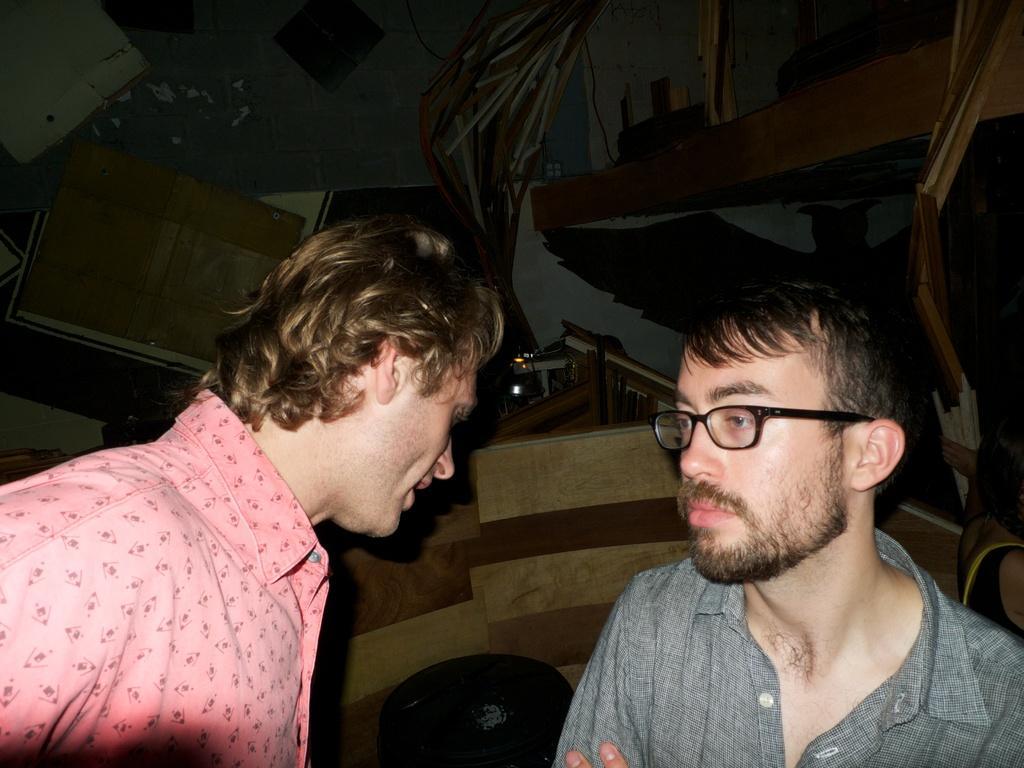In one or two sentences, can you explain what this image depicts? In this image we can see men. In the background there is a wall. 